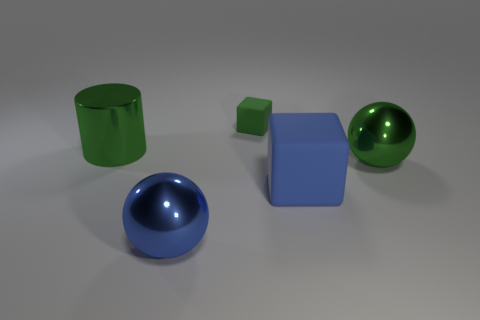Add 1 large blue matte cylinders. How many objects exist? 6 Subtract all blocks. How many objects are left? 3 Add 5 rubber things. How many rubber things exist? 7 Subtract 0 brown cylinders. How many objects are left? 5 Subtract all large cylinders. Subtract all small green things. How many objects are left? 3 Add 3 tiny matte cubes. How many tiny matte cubes are left? 4 